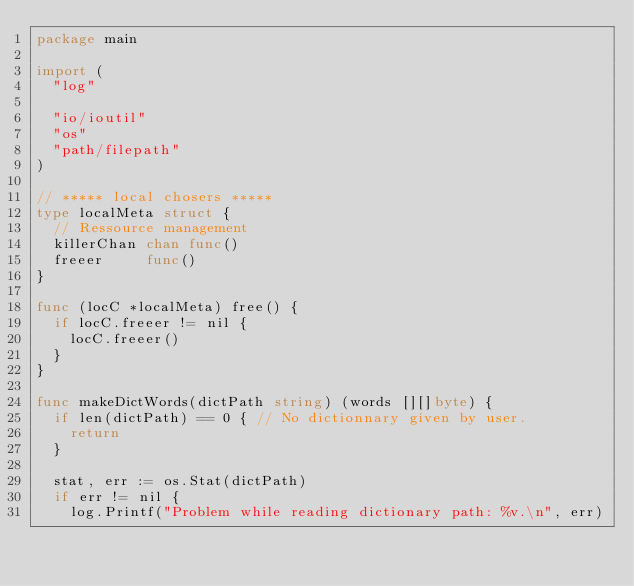Convert code to text. <code><loc_0><loc_0><loc_500><loc_500><_Go_>package main

import (
	"log"

	"io/ioutil"
	"os"
	"path/filepath"
)

// ***** local chosers *****
type localMeta struct {
	// Ressource management
	killerChan chan func()
	freeer     func()
}

func (locC *localMeta) free() {
	if locC.freeer != nil {
		locC.freeer()
	}
}

func makeDictWords(dictPath string) (words [][]byte) {
	if len(dictPath) == 0 { // No dictionnary given by user.
		return
	}

	stat, err := os.Stat(dictPath)
	if err != nil {
		log.Printf("Problem while reading dictionary path: %v.\n", err)</code> 